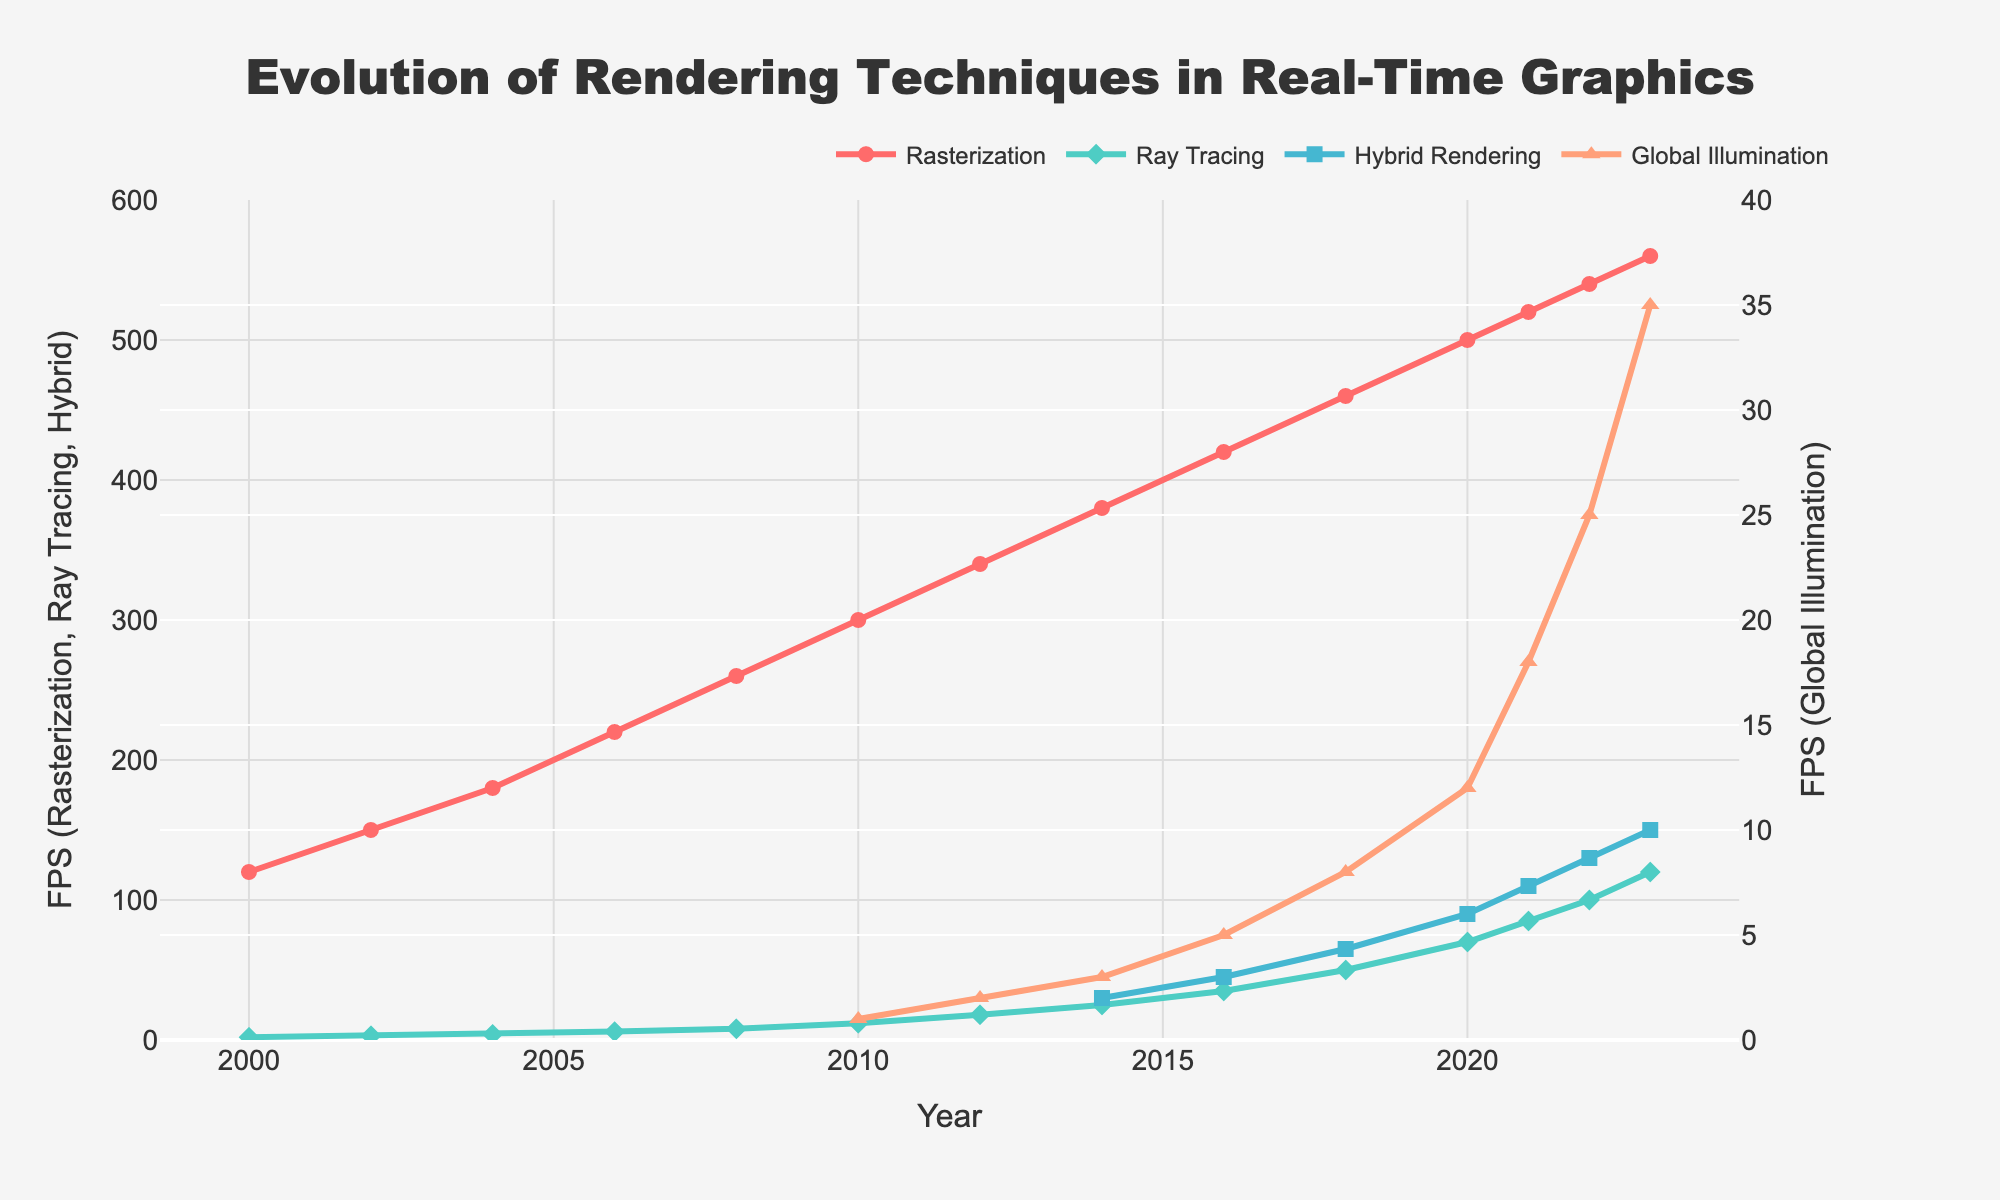What is the range of FPS for Rasterization from 2000 to 2023? To find the range, identify the minimum and maximum values of FPS for Rasterization within the given period. The values range from 120 FPS (in 2000) to 560 FPS (in 2023). The range is 560 - 120 = 440 FPS.
Answer: 440 FPS By how much did the Ray Tracing FPS increase from 2010 to 2023? First, find the FPS values for Ray Tracing in 2010 and 2023. In 2010, it was 12 FPS. In 2023, it was 120 FPS. Subtract the 2010 value from the 2023 value: 120 - 12 = 108 FPS.
Answer: 108 FPS Which technique has the greatest increase in FPS between any two consecutive years? Compare the year-over-year FPS increases for each technique. The largest increase is found between 2021 and 2022 for Ray Tracing, which increased by 15 FPS (from 85 to 100 FPS).
Answer: Ray Tracing What is the average FPS for Global Illumination from 2010 to 2023? First, list the FPS values for Global Illumination between 2010 and 2023: 1, 2, 3, 5, 8, 12, 18, 25, 35. Then, sum these values: 1+2+3+5+8+12+18+25+35 = 109. Divide by the number of years (9), so 109 / 9 ≈ 12.11 FPS.
Answer: 12.11 FPS Which rendering technique consistently had the highest FPS across the study period? By visually inspecting the trend lines, Rasterization consistently maintains the highest FPS across all the years from 2000 to 2023.
Answer: Rasterization What year did Hybrid Rendering FPS surpass 100 FPS? By inspecting the Hybrid Rendering trend, we see it surpasses 100 FPS in 2022.
Answer: 2022 In 2016, what was the difference between Ray Tracing FPS and Global Illumination FPS? Identify the FPS values for Ray Tracing and Global Illumination in 2016. Ray Tracing was at 35 FPS, while Global Illumination was at 5 FPS. The difference is 35 - 5 = 30 FPS.
Answer: 30 FPS How did the FPS of Global Illumination change from 2010 to 2020? In 2010, Global Illumination had an FPS of 1, and in 2020, it had an FPS of 12. The change is 12 - 1 = 11 FPS.
Answer: 11 FPS In which year did Global Illumination FPS become equal to Hybrid Rendering FPS? By examining the lines, in 2023 both Global Illumination and Hybrid Rendering have the same FPS at 35.
Answer: 2023 